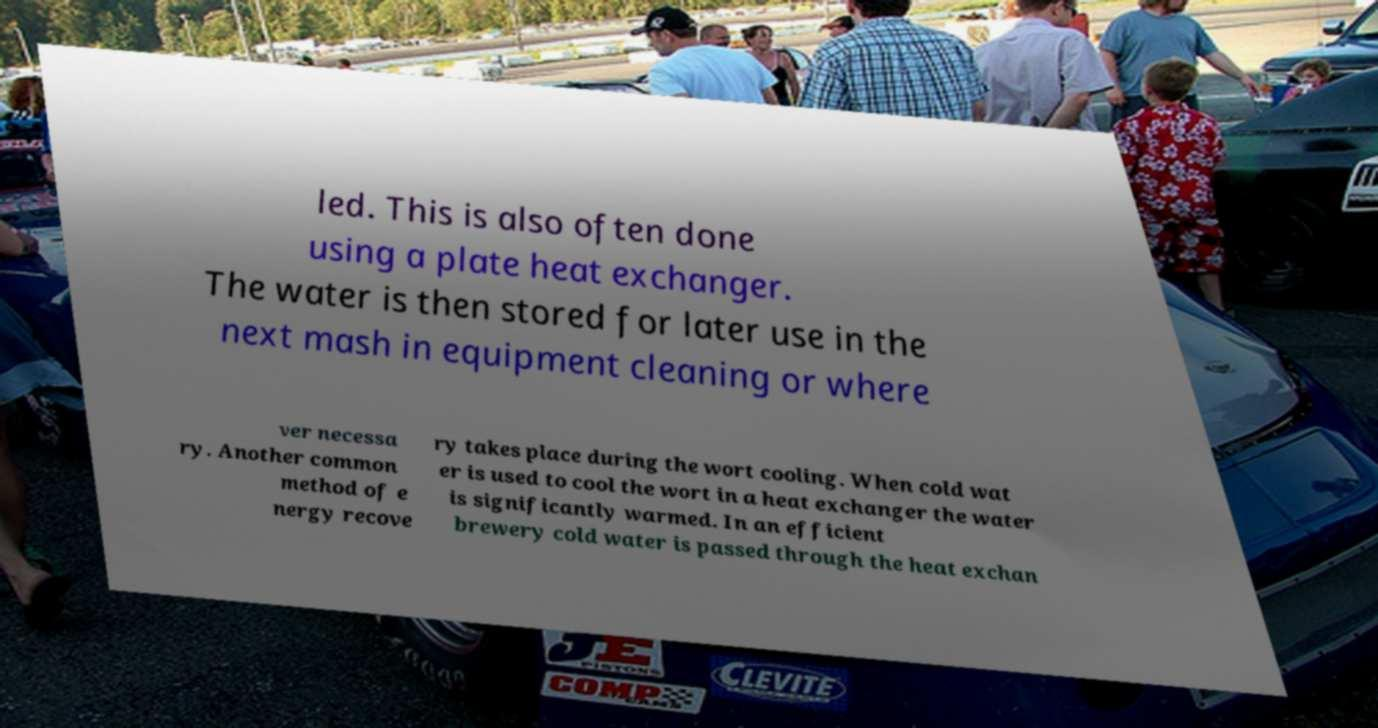What messages or text are displayed in this image? I need them in a readable, typed format. led. This is also often done using a plate heat exchanger. The water is then stored for later use in the next mash in equipment cleaning or where ver necessa ry. Another common method of e nergy recove ry takes place during the wort cooling. When cold wat er is used to cool the wort in a heat exchanger the water is significantly warmed. In an efficient brewery cold water is passed through the heat exchan 